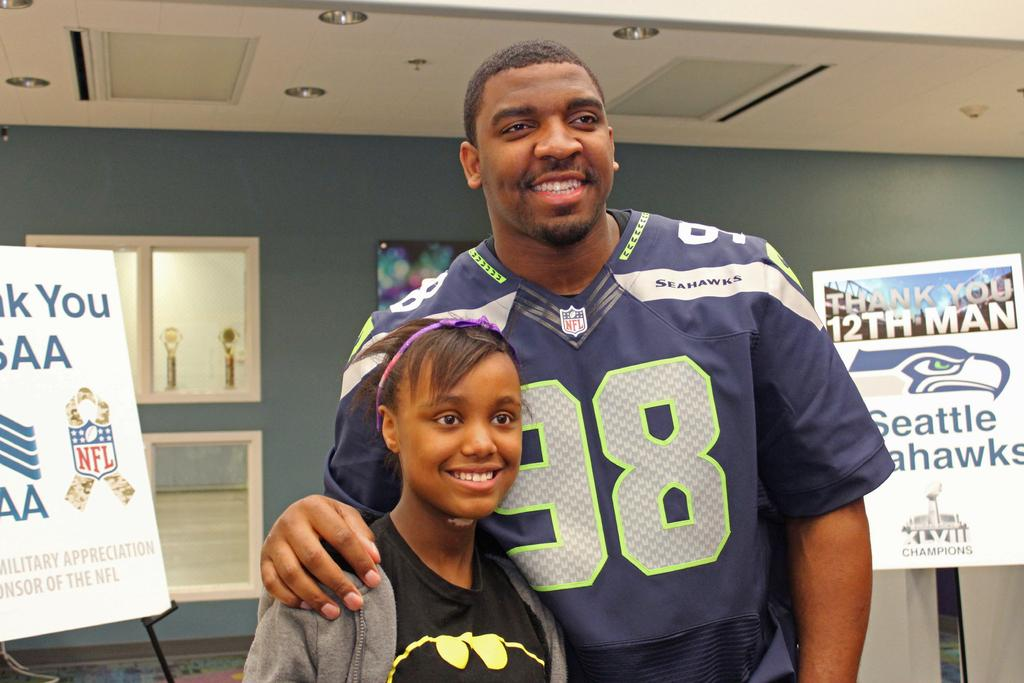<image>
Share a concise interpretation of the image provided. A football player wearing a Seahawks number 98 jersey. 